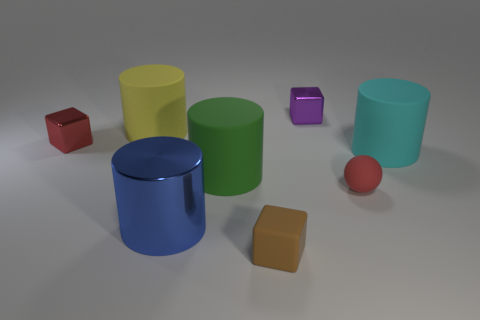Are the red thing to the right of the tiny purple metal cube and the big cyan thing made of the same material?
Ensure brevity in your answer.  Yes. How big is the metallic block that is in front of the large cylinder that is behind the tiny metallic block in front of the yellow rubber cylinder?
Your response must be concise. Small. How many other things are the same color as the big shiny cylinder?
Give a very brief answer. 0. There is a red shiny thing that is the same size as the red sphere; what is its shape?
Your response must be concise. Cube. What is the size of the rubber cylinder that is right of the purple shiny block?
Your answer should be very brief. Large. Does the tiny cube in front of the big shiny object have the same color as the tiny shiny block that is on the left side of the blue cylinder?
Provide a short and direct response. No. The cylinder that is in front of the tiny red thing right of the cube that is left of the shiny cylinder is made of what material?
Your response must be concise. Metal. Is there a purple rubber cylinder that has the same size as the purple cube?
Keep it short and to the point. No. There is a cyan cylinder that is the same size as the yellow thing; what material is it?
Offer a terse response. Rubber. There is a metallic object that is in front of the cyan thing; what shape is it?
Give a very brief answer. Cylinder. 